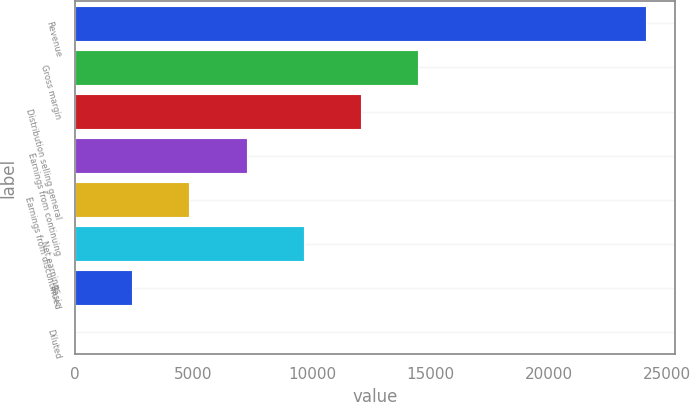<chart> <loc_0><loc_0><loc_500><loc_500><bar_chart><fcel>Revenue<fcel>Gross margin<fcel>Distribution selling general<fcel>Earnings from continuing<fcel>Earnings from discontinued<fcel>Net earnings<fcel>Basic<fcel>Diluted<nl><fcel>24117.8<fcel>14470.9<fcel>12059.1<fcel>7235.66<fcel>4823.93<fcel>9647.39<fcel>2412.2<fcel>0.47<nl></chart> 